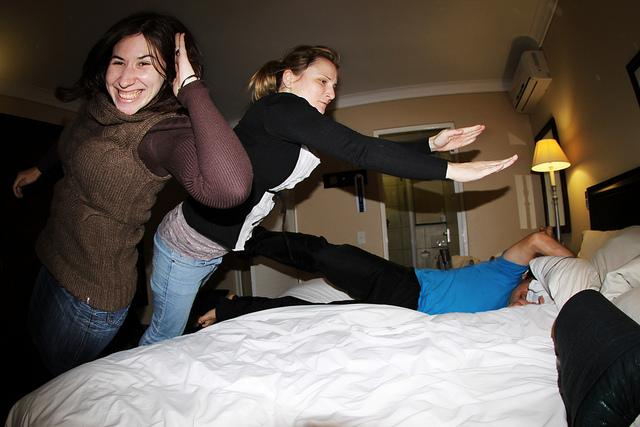Where are these people? hotel 